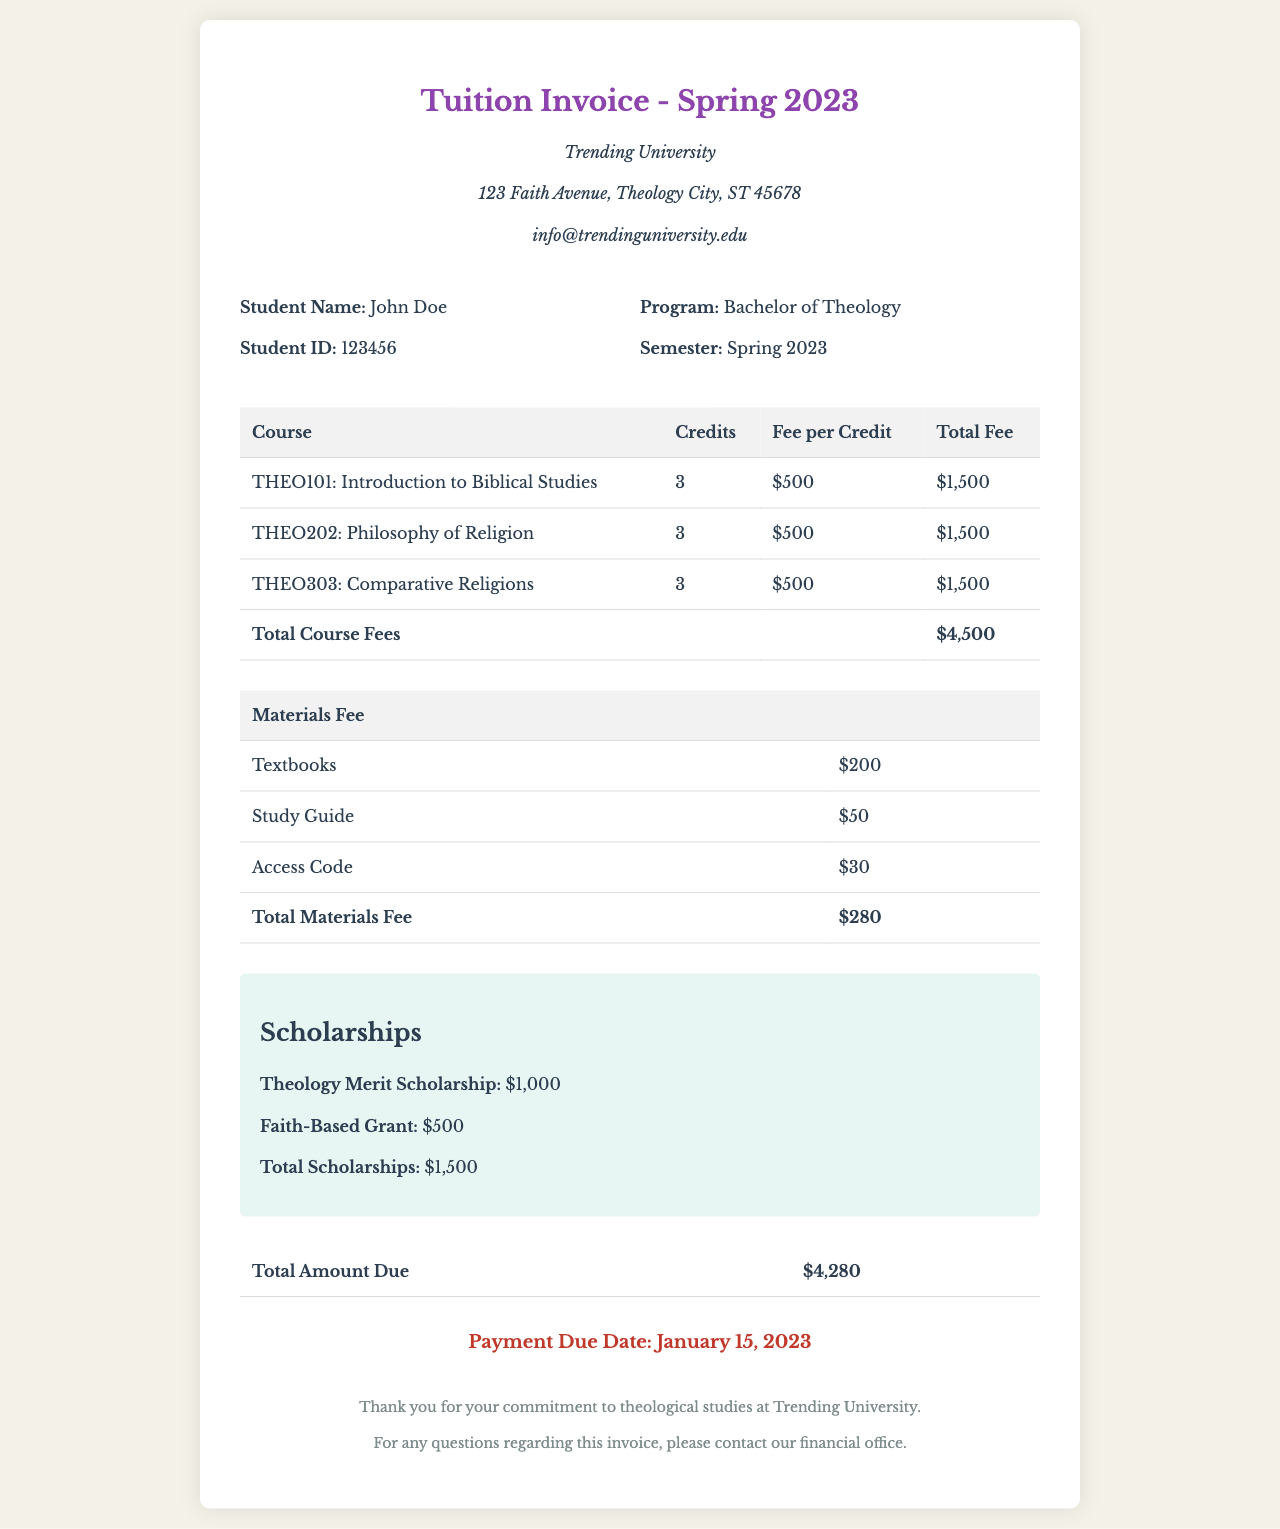What is the total course fee? The total course fee is calculated by summing the fees for each course listed, which amounts to $4,500.
Answer: $4,500 What is the total materials fee? The total materials fee is the sum of all material costs listed, which amounts to $280.
Answer: $280 What is the total amount due? The total amount due is the final amount after deducting scholarships from the combined course and materials fees, which totals $4,280.
Answer: $4,280 How much is the Theology Merit Scholarship? The Theology Merit Scholarship is specifically listed as a scholarship in the document which amounts to $1,000.
Answer: $1,000 What is the payment due date? The payment due date is explicitly stated at the end of the document as January 15, 2023.
Answer: January 15, 2023 How many credits is THEO202: Philosophy of Religion worth? The document clearly indicates that THEO202: Philosophy of Religion is worth 3 credits.
Answer: 3 What is the institution name? The institution name is prominently displayed in the header of the document, identified as Trending University.
Answer: Trending University What are the names of the scholarships listed? The scholarships listed include the Theology Merit Scholarship and the Faith-Based Grant.
Answer: Theology Merit Scholarship, Faith-Based Grant What program is John Doe enrolled in? The document specifies that John Doe is enrolled in the Bachelor of Theology program.
Answer: Bachelor of Theology 